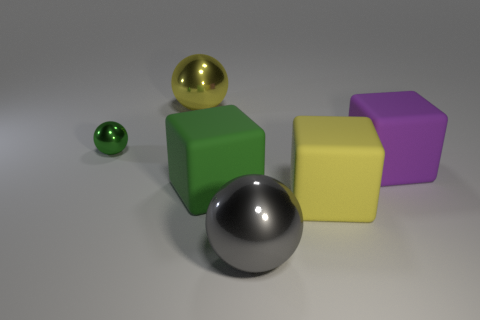Subtract all large shiny balls. How many balls are left? 1 Add 4 tiny shiny spheres. How many objects exist? 10 Subtract all green balls. How many balls are left? 2 Subtract 1 balls. How many balls are left? 2 Add 4 purple matte blocks. How many purple matte blocks exist? 5 Subtract 0 red blocks. How many objects are left? 6 Subtract all cyan blocks. Subtract all cyan balls. How many blocks are left? 3 Subtract all big yellow metallic balls. Subtract all yellow blocks. How many objects are left? 4 Add 3 big yellow rubber things. How many big yellow rubber things are left? 4 